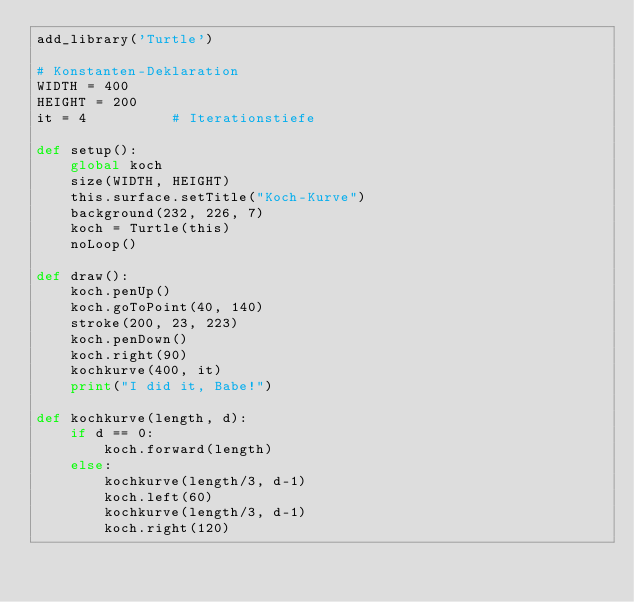<code> <loc_0><loc_0><loc_500><loc_500><_Python_>add_library('Turtle')

# Konstanten-Deklaration
WIDTH = 400
HEIGHT = 200
it = 4          # Iterationstiefe

def setup():
    global koch
    size(WIDTH, HEIGHT)
    this.surface.setTitle("Koch-Kurve")
    background(232, 226, 7)
    koch = Turtle(this)
    noLoop()

def draw():
    koch.penUp()
    koch.goToPoint(40, 140)
    stroke(200, 23, 223)
    koch.penDown()
    koch.right(90)
    kochkurve(400, it)
    print("I did it, Babe!")

def kochkurve(length, d):
    if d == 0:
        koch.forward(length)
    else:
        kochkurve(length/3, d-1)
        koch.left(60)
        kochkurve(length/3, d-1)
        koch.right(120)</code> 